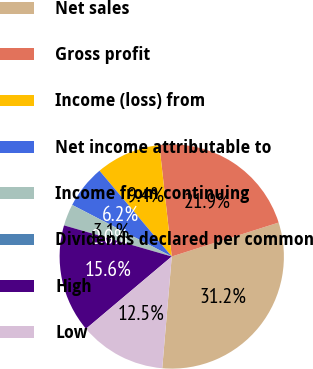Convert chart. <chart><loc_0><loc_0><loc_500><loc_500><pie_chart><fcel>Net sales<fcel>Gross profit<fcel>Income (loss) from<fcel>Net income attributable to<fcel>Income from continuing<fcel>Dividends declared per common<fcel>High<fcel>Low<nl><fcel>31.25%<fcel>21.87%<fcel>9.38%<fcel>6.25%<fcel>3.13%<fcel>0.0%<fcel>15.62%<fcel>12.5%<nl></chart> 